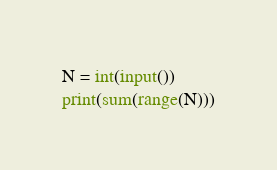Convert code to text. <code><loc_0><loc_0><loc_500><loc_500><_Python_>N = int(input())
print(sum(range(N)))</code> 